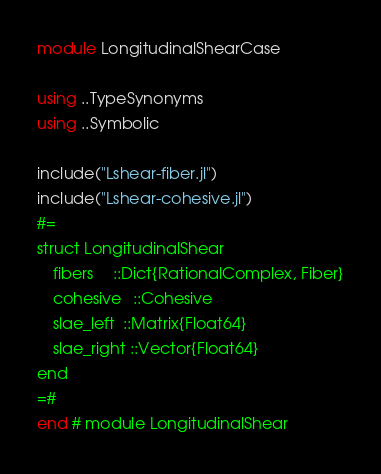<code> <loc_0><loc_0><loc_500><loc_500><_Julia_>module LongitudinalShearCase

using ..TypeSynonyms
using ..Symbolic

include("Lshear-fiber.jl")
include("Lshear-cohesive.jl")
#=
struct LongitudinalShear
    fibers     ::Dict{RationalComplex, Fiber}
    cohesive   ::Cohesive
    slae_left  ::Matrix{Float64}
    slae_right ::Vector{Float64}
end
=#
end # module LongitudinalShear</code> 